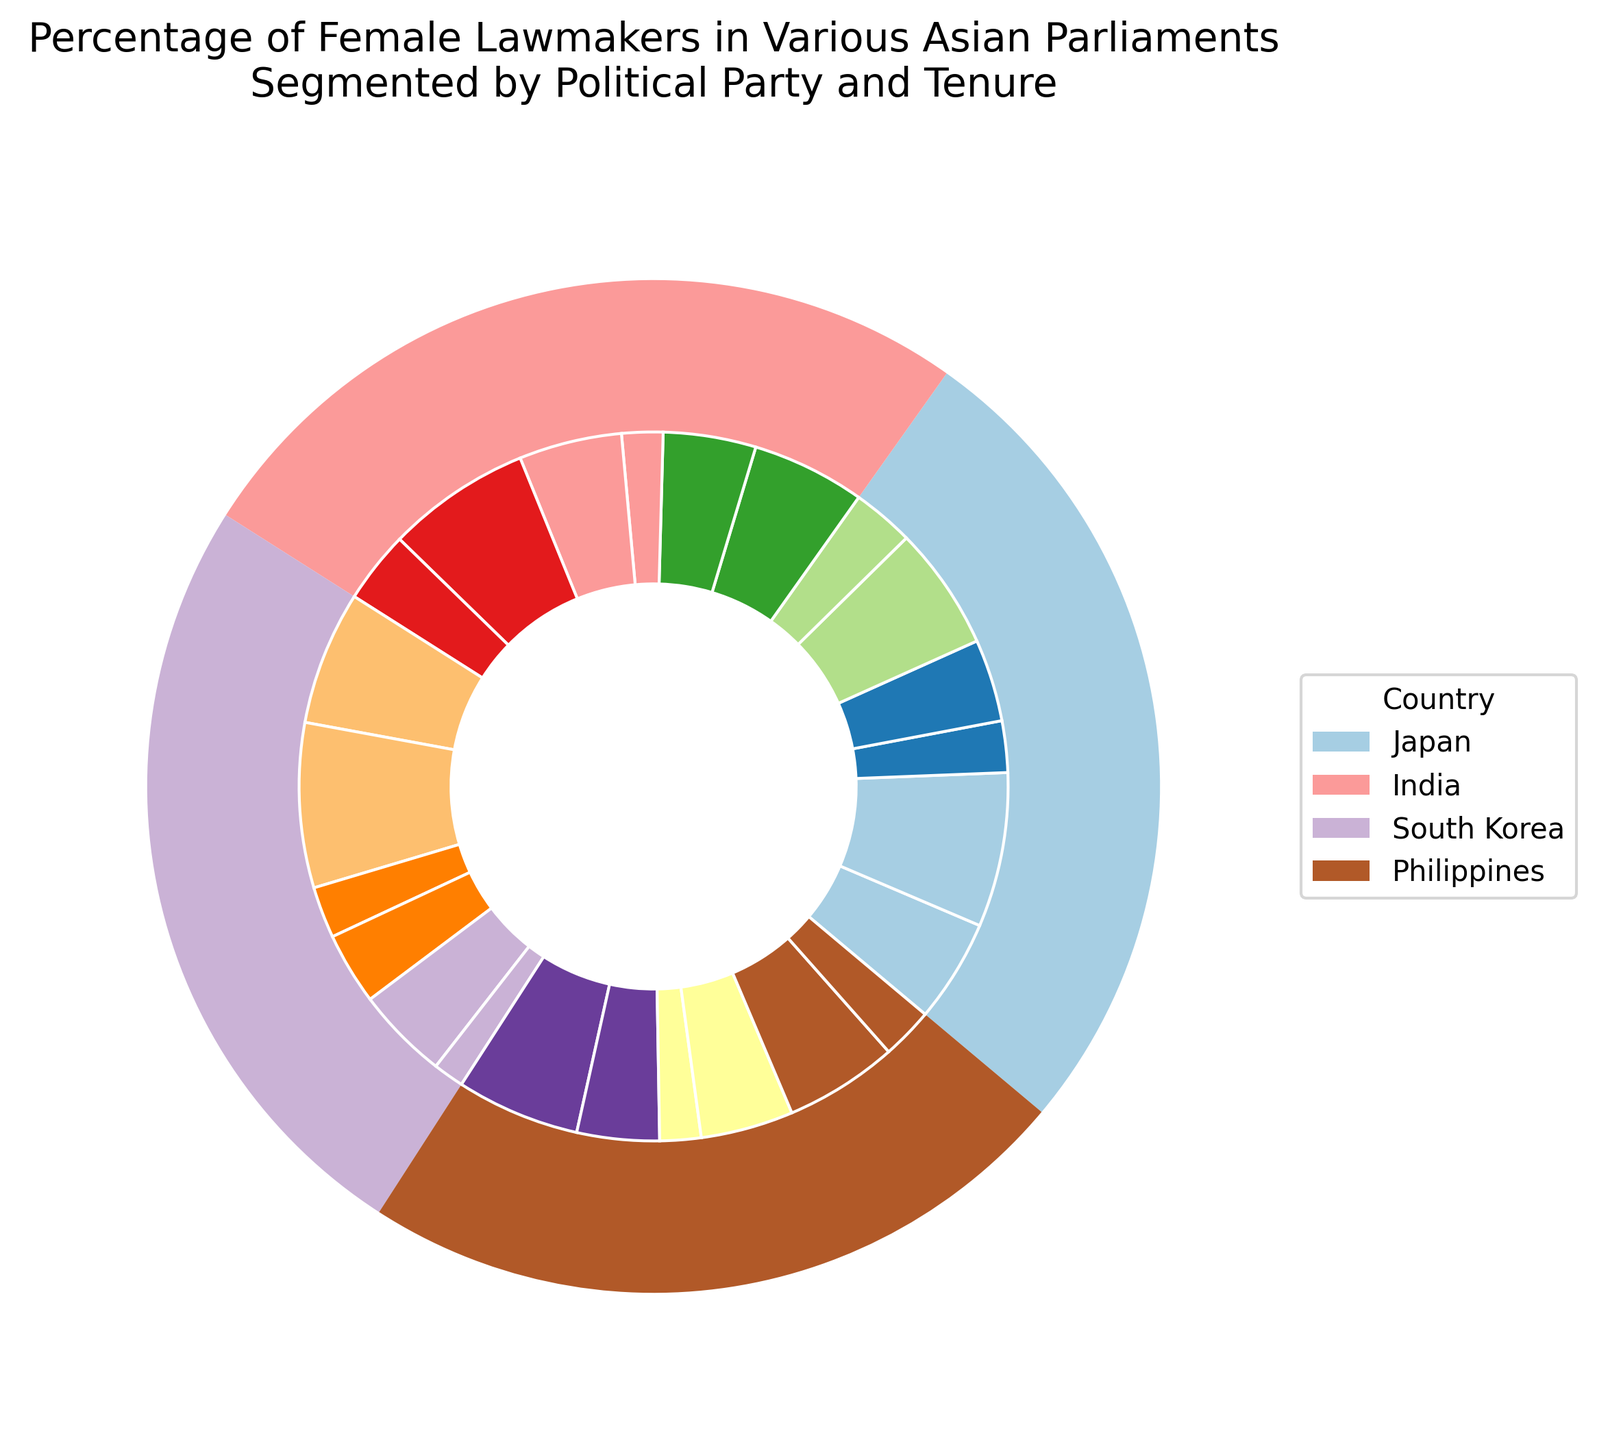What percentage of female lawmakers does India have for Party C across all terms? Add the percentages for each term: First Term (11%), Second Term (9%), Third Term (4%). The total is 11% + 9% + 4% = 24%.
Answer: 24% Which country has the highest total percentage of female lawmakers? Compare the summed percentages of all terms across each country. Japan: 56%, India: 55%, South Korea: 53%, Philippines: 54%. Japan has the highest total percentage at 56%.
Answer: Japan What is the total percentage of third-term female lawmakers in the Philippines for both parties? Add the third-term percentages for Party G (4%) and Party H (5%). The total is 4% + 5% = 9%.
Answer: 9% How does the percentage of first-term female lawmakers for Party E in South Korea compare to Party G in the Philippines? First-term percentage for Party E (South Korea) is 13% and for Party G (Philippines) is 12%. Thus, Party E has a higher percentage.
Answer: Party E has a higher percentage What is the average percentage of female lawmakers per term for Party A in Japan? Add the percentages for each term and divide by the number of terms: (10% + 15% + 5%) / 3. The result is 30% / 3 = 10%.
Answer: 10% What is the difference in percentage between second-term and third-term female lawmakers in South Korea for Party F? Second-term percentage is 9% and third-term percentage is 3%. The difference is 9% - 3% = 6%.
Answer: 6% How are the female lawmakers distributed across tenures for Party D in India? The distribution is First Term (10%), Second Term (14%), Third Term (7%).
Answer: 10%, 14%, 7% Which political party in South Korea has more female lawmakers in the second term: Party E or Party F? Compare the second-term percentages: Party E (16%) vs. Party F (9%). Party E has more female lawmakers.
Answer: Party E What is the total percentage of female lawmakers for all third terms combined across all countries? Add all third-term percentages across countries: Japan (5% + 6% = 11%), India (4% + 7% = 11%), South Korea (5% + 3% = 8%), Philippines (4% + 5% = 9%). The total is 11% + 11% + 8% + 9% = 39%.
Answer: 39% 